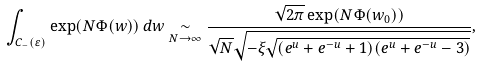Convert formula to latex. <formula><loc_0><loc_0><loc_500><loc_500>\int _ { C _ { - } ( \varepsilon ) } \exp ( N \Phi ( w ) ) \, d w \underset { N \to \infty } { \sim } \frac { \sqrt { 2 \pi } \exp ( N \Phi ( w _ { 0 } ) ) } { \sqrt { N } \sqrt { - \xi \sqrt { ( e ^ { u } + e ^ { - u } + 1 ) ( e ^ { u } + e ^ { - u } - 3 ) } } } ,</formula> 